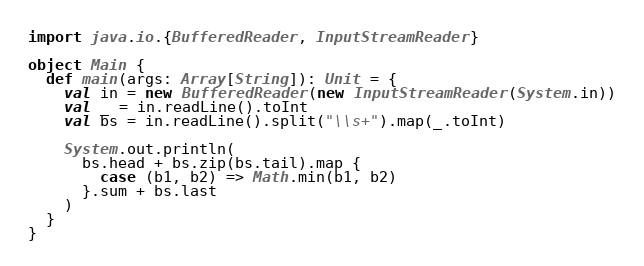<code> <loc_0><loc_0><loc_500><loc_500><_Scala_>import java.io.{BufferedReader, InputStreamReader}

object Main {
  def main(args: Array[String]): Unit = {
    val in = new BufferedReader(new InputStreamReader(System.in))
    val _ = in.readLine().toInt
    val bs = in.readLine().split("\\s+").map(_.toInt)

    System.out.println(
      bs.head + bs.zip(bs.tail).map {
        case (b1, b2) => Math.min(b1, b2)
      }.sum + bs.last
    )
  }
}
</code> 